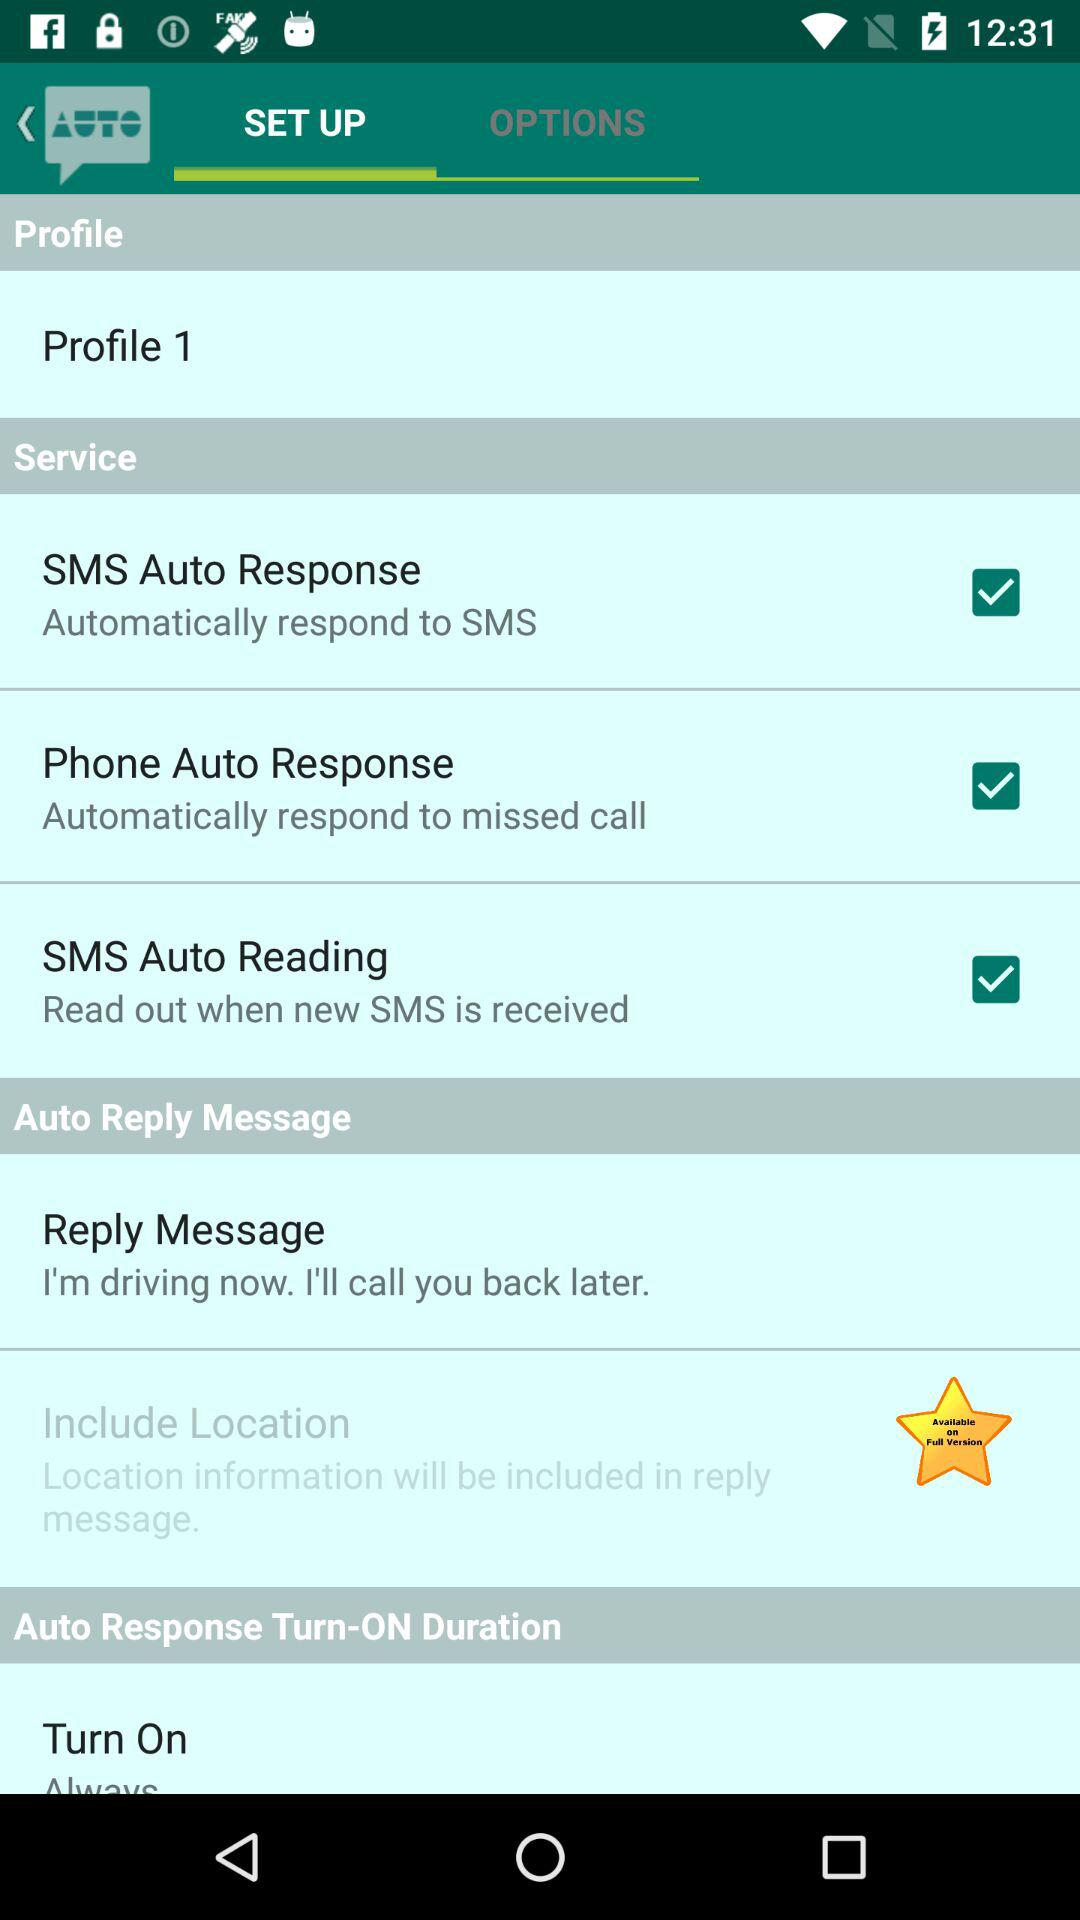What is the status of the Phone Auto Response Service? The status is "on". 